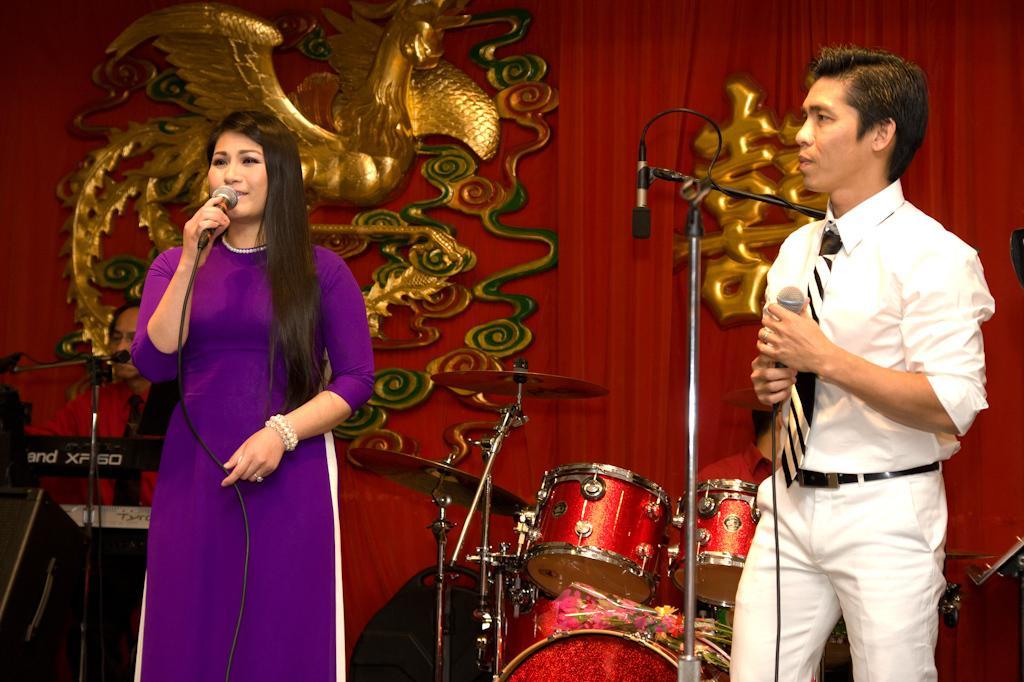Please provide a concise description of this image. On the right side of the image we can see persons standing and holding mic. On the left side of the image we can see woman standing and holding mic. In the background we can see musical instruments, person, decors and curtain. 